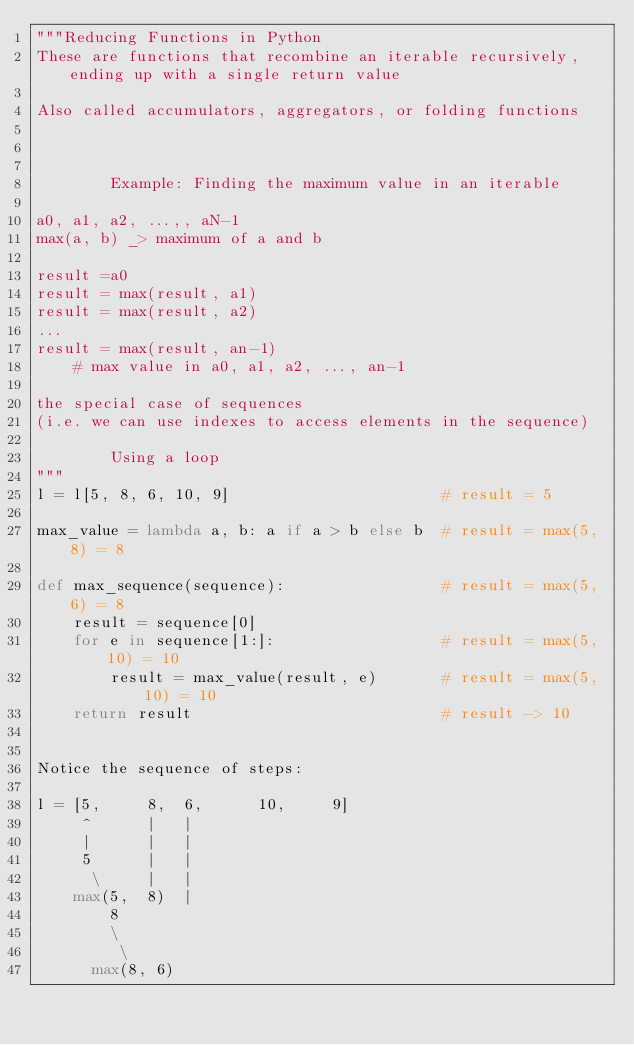<code> <loc_0><loc_0><loc_500><loc_500><_Python_>"""Reducing Functions in Python
These are functions that recombine an iterable recursively, ending up with a single return value

Also called accumulators, aggregators, or folding functions



        Example: Finding the maximum value in an iterable

a0, a1, a2, ...,, aN-1
max(a, b) _> maximum of a and b

result =a0
result = max(result, a1)
result = max(result, a2)
...
result = max(result, an-1)
    # max value in a0, a1, a2, ..., an-1

the special case of sequences
(i.e. we can use indexes to access elements in the sequence)

        Using a loop
"""
l = l[5, 8, 6, 10, 9]                       # result = 5

max_value = lambda a, b: a if a > b else b  # result = max(5, 8) = 8

def max_sequence(sequence):                 # result = max(5, 6) = 8
    result = sequence[0]
    for e in sequence[1:]:                  # result = max(5, 10) = 10
        result = max_value(result, e)       # result = max(5, 10) = 10
    return result                           # result -> 10


Notice the sequence of steps:

l = [5,     8,  6,      10,     9]
     ^      |   |
     |      |   |
     5      |   |
      \     |   |
    max(5,  8)  |
        8       
        \
         \
      max(8, 6)</code> 